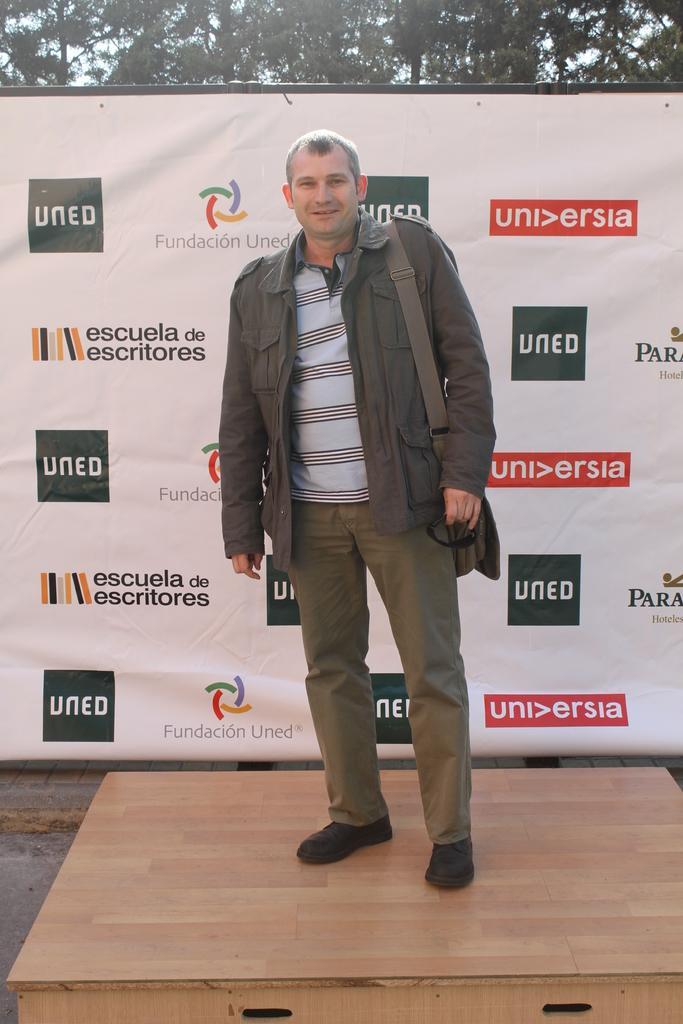How would you summarize this image in a sentence or two? A man is standing and smiling behind him there is a banner and trees. 